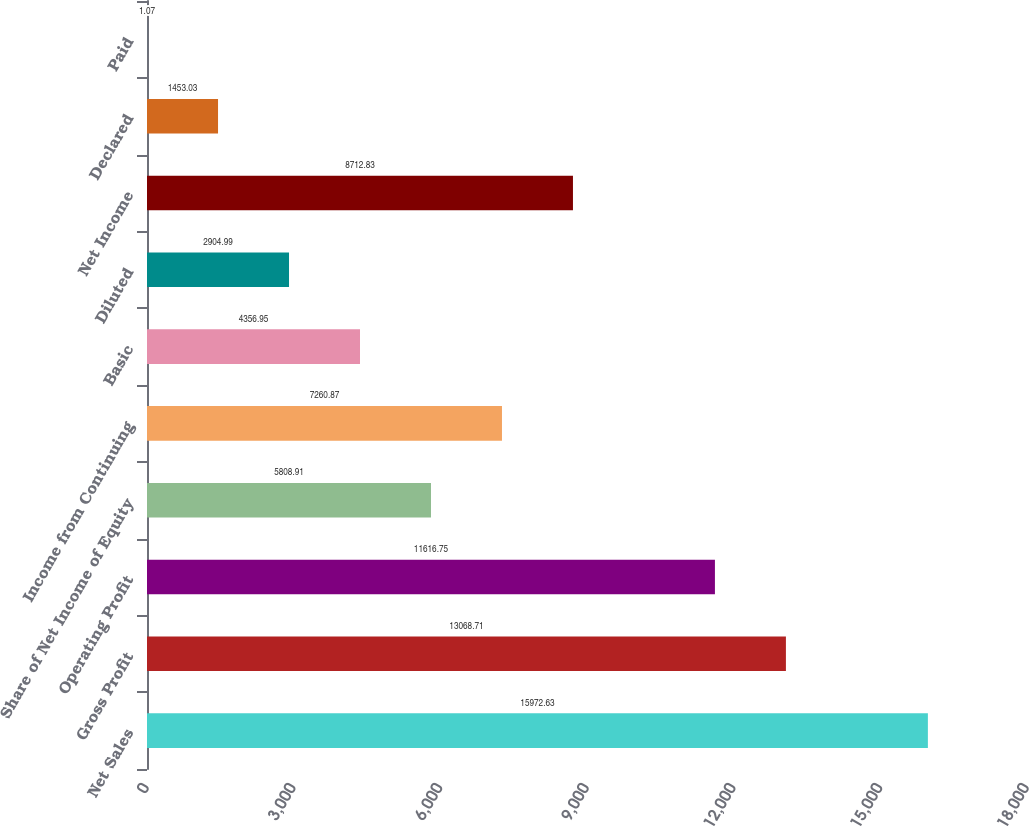Convert chart to OTSL. <chart><loc_0><loc_0><loc_500><loc_500><bar_chart><fcel>Net Sales<fcel>Gross Profit<fcel>Operating Profit<fcel>Share of Net Income of Equity<fcel>Income from Continuing<fcel>Basic<fcel>Diluted<fcel>Net Income<fcel>Declared<fcel>Paid<nl><fcel>15972.6<fcel>13068.7<fcel>11616.8<fcel>5808.91<fcel>7260.87<fcel>4356.95<fcel>2904.99<fcel>8712.83<fcel>1453.03<fcel>1.07<nl></chart> 